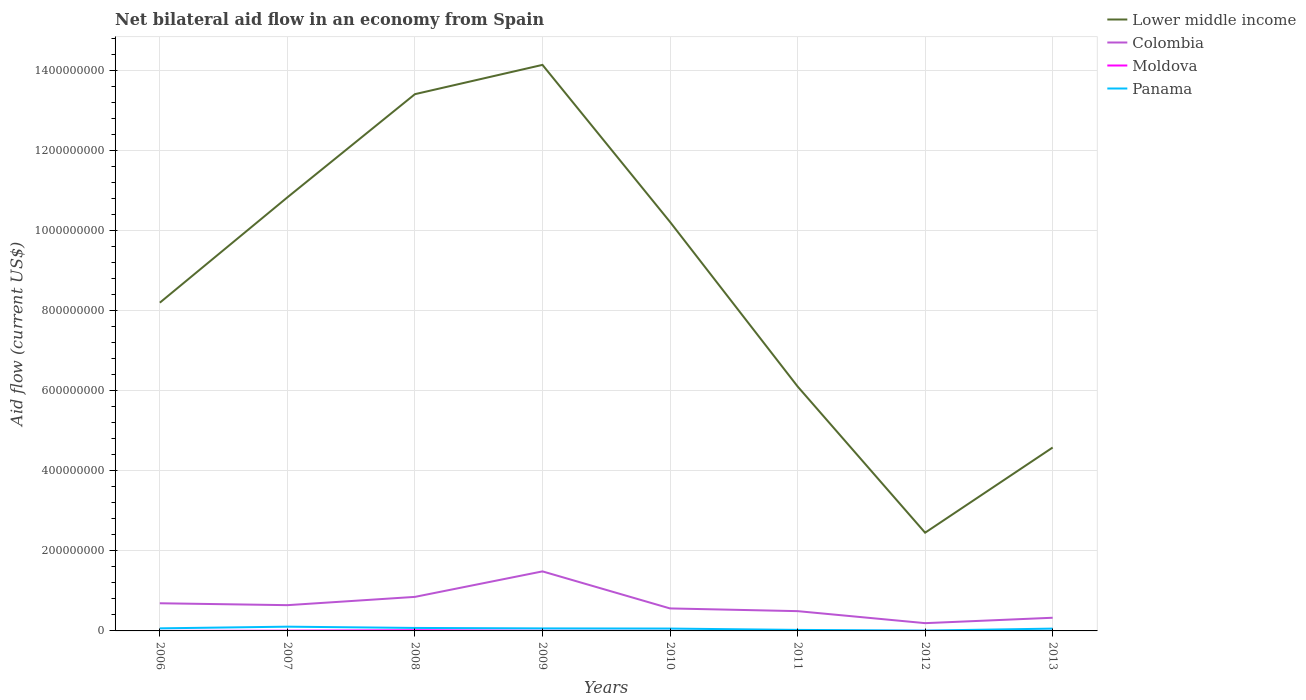Is the number of lines equal to the number of legend labels?
Provide a succinct answer. Yes. Across all years, what is the maximum net bilateral aid flow in Moldova?
Make the answer very short. 10000. What is the total net bilateral aid flow in Panama in the graph?
Ensure brevity in your answer.  4.83e+06. What is the difference between the highest and the second highest net bilateral aid flow in Colombia?
Make the answer very short. 1.29e+08. What is the difference between the highest and the lowest net bilateral aid flow in Moldova?
Ensure brevity in your answer.  3. Is the net bilateral aid flow in Colombia strictly greater than the net bilateral aid flow in Panama over the years?
Your answer should be very brief. No. How many years are there in the graph?
Make the answer very short. 8. What is the difference between two consecutive major ticks on the Y-axis?
Keep it short and to the point. 2.00e+08. Does the graph contain any zero values?
Your answer should be very brief. No. Does the graph contain grids?
Ensure brevity in your answer.  Yes. How many legend labels are there?
Make the answer very short. 4. What is the title of the graph?
Provide a succinct answer. Net bilateral aid flow in an economy from Spain. Does "Comoros" appear as one of the legend labels in the graph?
Your answer should be compact. No. What is the label or title of the X-axis?
Provide a succinct answer. Years. What is the Aid flow (current US$) in Lower middle income in 2006?
Keep it short and to the point. 8.19e+08. What is the Aid flow (current US$) in Colombia in 2006?
Provide a short and direct response. 6.90e+07. What is the Aid flow (current US$) in Moldova in 2006?
Ensure brevity in your answer.  10000. What is the Aid flow (current US$) of Panama in 2006?
Your answer should be compact. 6.43e+06. What is the Aid flow (current US$) of Lower middle income in 2007?
Your answer should be very brief. 1.08e+09. What is the Aid flow (current US$) in Colombia in 2007?
Provide a short and direct response. 6.43e+07. What is the Aid flow (current US$) of Moldova in 2007?
Give a very brief answer. 6.50e+05. What is the Aid flow (current US$) in Panama in 2007?
Your answer should be compact. 1.06e+07. What is the Aid flow (current US$) of Lower middle income in 2008?
Provide a short and direct response. 1.34e+09. What is the Aid flow (current US$) of Colombia in 2008?
Offer a terse response. 8.50e+07. What is the Aid flow (current US$) in Moldova in 2008?
Your response must be concise. 1.80e+06. What is the Aid flow (current US$) in Panama in 2008?
Keep it short and to the point. 7.44e+06. What is the Aid flow (current US$) of Lower middle income in 2009?
Your answer should be very brief. 1.41e+09. What is the Aid flow (current US$) of Colombia in 2009?
Give a very brief answer. 1.49e+08. What is the Aid flow (current US$) in Moldova in 2009?
Make the answer very short. 3.90e+05. What is the Aid flow (current US$) in Panama in 2009?
Your answer should be very brief. 6.27e+06. What is the Aid flow (current US$) of Lower middle income in 2010?
Make the answer very short. 1.02e+09. What is the Aid flow (current US$) in Colombia in 2010?
Offer a terse response. 5.62e+07. What is the Aid flow (current US$) in Moldova in 2010?
Offer a very short reply. 6.00e+04. What is the Aid flow (current US$) in Panama in 2010?
Your response must be concise. 5.87e+06. What is the Aid flow (current US$) of Lower middle income in 2011?
Offer a terse response. 6.10e+08. What is the Aid flow (current US$) in Colombia in 2011?
Give a very brief answer. 4.94e+07. What is the Aid flow (current US$) of Panama in 2011?
Ensure brevity in your answer.  2.54e+06. What is the Aid flow (current US$) in Lower middle income in 2012?
Offer a very short reply. 2.45e+08. What is the Aid flow (current US$) of Colombia in 2012?
Provide a short and direct response. 1.94e+07. What is the Aid flow (current US$) in Panama in 2012?
Provide a succinct answer. 8.60e+05. What is the Aid flow (current US$) of Lower middle income in 2013?
Offer a terse response. 4.58e+08. What is the Aid flow (current US$) of Colombia in 2013?
Offer a very short reply. 3.29e+07. What is the Aid flow (current US$) of Panama in 2013?
Give a very brief answer. 5.77e+06. Across all years, what is the maximum Aid flow (current US$) in Lower middle income?
Provide a short and direct response. 1.41e+09. Across all years, what is the maximum Aid flow (current US$) of Colombia?
Ensure brevity in your answer.  1.49e+08. Across all years, what is the maximum Aid flow (current US$) of Moldova?
Your answer should be very brief. 1.80e+06. Across all years, what is the maximum Aid flow (current US$) of Panama?
Ensure brevity in your answer.  1.06e+07. Across all years, what is the minimum Aid flow (current US$) in Lower middle income?
Ensure brevity in your answer.  2.45e+08. Across all years, what is the minimum Aid flow (current US$) of Colombia?
Offer a very short reply. 1.94e+07. Across all years, what is the minimum Aid flow (current US$) in Moldova?
Your answer should be very brief. 10000. Across all years, what is the minimum Aid flow (current US$) in Panama?
Offer a very short reply. 8.60e+05. What is the total Aid flow (current US$) in Lower middle income in the graph?
Your response must be concise. 6.99e+09. What is the total Aid flow (current US$) in Colombia in the graph?
Give a very brief answer. 5.25e+08. What is the total Aid flow (current US$) of Panama in the graph?
Your response must be concise. 4.58e+07. What is the difference between the Aid flow (current US$) in Lower middle income in 2006 and that in 2007?
Provide a short and direct response. -2.63e+08. What is the difference between the Aid flow (current US$) in Colombia in 2006 and that in 2007?
Provide a short and direct response. 4.72e+06. What is the difference between the Aid flow (current US$) in Moldova in 2006 and that in 2007?
Offer a very short reply. -6.40e+05. What is the difference between the Aid flow (current US$) of Panama in 2006 and that in 2007?
Give a very brief answer. -4.17e+06. What is the difference between the Aid flow (current US$) of Lower middle income in 2006 and that in 2008?
Your answer should be very brief. -5.21e+08. What is the difference between the Aid flow (current US$) of Colombia in 2006 and that in 2008?
Keep it short and to the point. -1.60e+07. What is the difference between the Aid flow (current US$) in Moldova in 2006 and that in 2008?
Offer a very short reply. -1.79e+06. What is the difference between the Aid flow (current US$) of Panama in 2006 and that in 2008?
Make the answer very short. -1.01e+06. What is the difference between the Aid flow (current US$) in Lower middle income in 2006 and that in 2009?
Give a very brief answer. -5.94e+08. What is the difference between the Aid flow (current US$) of Colombia in 2006 and that in 2009?
Offer a terse response. -7.96e+07. What is the difference between the Aid flow (current US$) of Moldova in 2006 and that in 2009?
Provide a succinct answer. -3.80e+05. What is the difference between the Aid flow (current US$) of Panama in 2006 and that in 2009?
Provide a short and direct response. 1.60e+05. What is the difference between the Aid flow (current US$) in Lower middle income in 2006 and that in 2010?
Offer a terse response. -2.02e+08. What is the difference between the Aid flow (current US$) of Colombia in 2006 and that in 2010?
Your answer should be compact. 1.29e+07. What is the difference between the Aid flow (current US$) of Moldova in 2006 and that in 2010?
Give a very brief answer. -5.00e+04. What is the difference between the Aid flow (current US$) of Panama in 2006 and that in 2010?
Make the answer very short. 5.60e+05. What is the difference between the Aid flow (current US$) of Lower middle income in 2006 and that in 2011?
Keep it short and to the point. 2.09e+08. What is the difference between the Aid flow (current US$) of Colombia in 2006 and that in 2011?
Offer a very short reply. 1.96e+07. What is the difference between the Aid flow (current US$) in Moldova in 2006 and that in 2011?
Ensure brevity in your answer.  -3.00e+04. What is the difference between the Aid flow (current US$) in Panama in 2006 and that in 2011?
Keep it short and to the point. 3.89e+06. What is the difference between the Aid flow (current US$) of Lower middle income in 2006 and that in 2012?
Your response must be concise. 5.74e+08. What is the difference between the Aid flow (current US$) in Colombia in 2006 and that in 2012?
Offer a very short reply. 4.96e+07. What is the difference between the Aid flow (current US$) in Moldova in 2006 and that in 2012?
Offer a terse response. -10000. What is the difference between the Aid flow (current US$) in Panama in 2006 and that in 2012?
Provide a succinct answer. 5.57e+06. What is the difference between the Aid flow (current US$) of Lower middle income in 2006 and that in 2013?
Your answer should be compact. 3.62e+08. What is the difference between the Aid flow (current US$) in Colombia in 2006 and that in 2013?
Your answer should be compact. 3.61e+07. What is the difference between the Aid flow (current US$) in Moldova in 2006 and that in 2013?
Your answer should be compact. -2.00e+04. What is the difference between the Aid flow (current US$) of Panama in 2006 and that in 2013?
Provide a succinct answer. 6.60e+05. What is the difference between the Aid flow (current US$) of Lower middle income in 2007 and that in 2008?
Your response must be concise. -2.58e+08. What is the difference between the Aid flow (current US$) in Colombia in 2007 and that in 2008?
Your answer should be compact. -2.07e+07. What is the difference between the Aid flow (current US$) in Moldova in 2007 and that in 2008?
Your answer should be compact. -1.15e+06. What is the difference between the Aid flow (current US$) of Panama in 2007 and that in 2008?
Keep it short and to the point. 3.16e+06. What is the difference between the Aid flow (current US$) of Lower middle income in 2007 and that in 2009?
Give a very brief answer. -3.31e+08. What is the difference between the Aid flow (current US$) in Colombia in 2007 and that in 2009?
Provide a succinct answer. -8.43e+07. What is the difference between the Aid flow (current US$) of Moldova in 2007 and that in 2009?
Ensure brevity in your answer.  2.60e+05. What is the difference between the Aid flow (current US$) of Panama in 2007 and that in 2009?
Keep it short and to the point. 4.33e+06. What is the difference between the Aid flow (current US$) of Lower middle income in 2007 and that in 2010?
Your answer should be compact. 6.13e+07. What is the difference between the Aid flow (current US$) in Colombia in 2007 and that in 2010?
Ensure brevity in your answer.  8.15e+06. What is the difference between the Aid flow (current US$) of Moldova in 2007 and that in 2010?
Make the answer very short. 5.90e+05. What is the difference between the Aid flow (current US$) in Panama in 2007 and that in 2010?
Ensure brevity in your answer.  4.73e+06. What is the difference between the Aid flow (current US$) in Lower middle income in 2007 and that in 2011?
Provide a succinct answer. 4.72e+08. What is the difference between the Aid flow (current US$) of Colombia in 2007 and that in 2011?
Your response must be concise. 1.49e+07. What is the difference between the Aid flow (current US$) of Moldova in 2007 and that in 2011?
Give a very brief answer. 6.10e+05. What is the difference between the Aid flow (current US$) of Panama in 2007 and that in 2011?
Your response must be concise. 8.06e+06. What is the difference between the Aid flow (current US$) of Lower middle income in 2007 and that in 2012?
Ensure brevity in your answer.  8.37e+08. What is the difference between the Aid flow (current US$) in Colombia in 2007 and that in 2012?
Your answer should be very brief. 4.49e+07. What is the difference between the Aid flow (current US$) in Moldova in 2007 and that in 2012?
Provide a short and direct response. 6.30e+05. What is the difference between the Aid flow (current US$) of Panama in 2007 and that in 2012?
Keep it short and to the point. 9.74e+06. What is the difference between the Aid flow (current US$) of Lower middle income in 2007 and that in 2013?
Give a very brief answer. 6.24e+08. What is the difference between the Aid flow (current US$) in Colombia in 2007 and that in 2013?
Offer a terse response. 3.14e+07. What is the difference between the Aid flow (current US$) in Moldova in 2007 and that in 2013?
Offer a very short reply. 6.20e+05. What is the difference between the Aid flow (current US$) in Panama in 2007 and that in 2013?
Provide a short and direct response. 4.83e+06. What is the difference between the Aid flow (current US$) in Lower middle income in 2008 and that in 2009?
Offer a terse response. -7.31e+07. What is the difference between the Aid flow (current US$) in Colombia in 2008 and that in 2009?
Your response must be concise. -6.36e+07. What is the difference between the Aid flow (current US$) in Moldova in 2008 and that in 2009?
Keep it short and to the point. 1.41e+06. What is the difference between the Aid flow (current US$) in Panama in 2008 and that in 2009?
Give a very brief answer. 1.17e+06. What is the difference between the Aid flow (current US$) in Lower middle income in 2008 and that in 2010?
Your response must be concise. 3.19e+08. What is the difference between the Aid flow (current US$) of Colombia in 2008 and that in 2010?
Give a very brief answer. 2.88e+07. What is the difference between the Aid flow (current US$) in Moldova in 2008 and that in 2010?
Your response must be concise. 1.74e+06. What is the difference between the Aid flow (current US$) of Panama in 2008 and that in 2010?
Provide a short and direct response. 1.57e+06. What is the difference between the Aid flow (current US$) in Lower middle income in 2008 and that in 2011?
Make the answer very short. 7.30e+08. What is the difference between the Aid flow (current US$) in Colombia in 2008 and that in 2011?
Your answer should be very brief. 3.56e+07. What is the difference between the Aid flow (current US$) in Moldova in 2008 and that in 2011?
Ensure brevity in your answer.  1.76e+06. What is the difference between the Aid flow (current US$) of Panama in 2008 and that in 2011?
Provide a short and direct response. 4.90e+06. What is the difference between the Aid flow (current US$) in Lower middle income in 2008 and that in 2012?
Your response must be concise. 1.09e+09. What is the difference between the Aid flow (current US$) of Colombia in 2008 and that in 2012?
Provide a succinct answer. 6.56e+07. What is the difference between the Aid flow (current US$) in Moldova in 2008 and that in 2012?
Offer a terse response. 1.78e+06. What is the difference between the Aid flow (current US$) of Panama in 2008 and that in 2012?
Make the answer very short. 6.58e+06. What is the difference between the Aid flow (current US$) of Lower middle income in 2008 and that in 2013?
Provide a short and direct response. 8.82e+08. What is the difference between the Aid flow (current US$) of Colombia in 2008 and that in 2013?
Your answer should be very brief. 5.21e+07. What is the difference between the Aid flow (current US$) of Moldova in 2008 and that in 2013?
Give a very brief answer. 1.77e+06. What is the difference between the Aid flow (current US$) in Panama in 2008 and that in 2013?
Your answer should be very brief. 1.67e+06. What is the difference between the Aid flow (current US$) of Lower middle income in 2009 and that in 2010?
Your answer should be compact. 3.92e+08. What is the difference between the Aid flow (current US$) in Colombia in 2009 and that in 2010?
Your answer should be very brief. 9.25e+07. What is the difference between the Aid flow (current US$) in Lower middle income in 2009 and that in 2011?
Provide a succinct answer. 8.03e+08. What is the difference between the Aid flow (current US$) in Colombia in 2009 and that in 2011?
Offer a terse response. 9.92e+07. What is the difference between the Aid flow (current US$) of Panama in 2009 and that in 2011?
Keep it short and to the point. 3.73e+06. What is the difference between the Aid flow (current US$) of Lower middle income in 2009 and that in 2012?
Make the answer very short. 1.17e+09. What is the difference between the Aid flow (current US$) of Colombia in 2009 and that in 2012?
Give a very brief answer. 1.29e+08. What is the difference between the Aid flow (current US$) of Panama in 2009 and that in 2012?
Provide a succinct answer. 5.41e+06. What is the difference between the Aid flow (current US$) in Lower middle income in 2009 and that in 2013?
Offer a terse response. 9.55e+08. What is the difference between the Aid flow (current US$) of Colombia in 2009 and that in 2013?
Your response must be concise. 1.16e+08. What is the difference between the Aid flow (current US$) in Lower middle income in 2010 and that in 2011?
Your response must be concise. 4.11e+08. What is the difference between the Aid flow (current US$) in Colombia in 2010 and that in 2011?
Give a very brief answer. 6.76e+06. What is the difference between the Aid flow (current US$) in Moldova in 2010 and that in 2011?
Your response must be concise. 2.00e+04. What is the difference between the Aid flow (current US$) in Panama in 2010 and that in 2011?
Provide a succinct answer. 3.33e+06. What is the difference between the Aid flow (current US$) in Lower middle income in 2010 and that in 2012?
Your response must be concise. 7.76e+08. What is the difference between the Aid flow (current US$) of Colombia in 2010 and that in 2012?
Give a very brief answer. 3.68e+07. What is the difference between the Aid flow (current US$) of Moldova in 2010 and that in 2012?
Keep it short and to the point. 4.00e+04. What is the difference between the Aid flow (current US$) in Panama in 2010 and that in 2012?
Your response must be concise. 5.01e+06. What is the difference between the Aid flow (current US$) of Lower middle income in 2010 and that in 2013?
Provide a short and direct response. 5.63e+08. What is the difference between the Aid flow (current US$) in Colombia in 2010 and that in 2013?
Provide a succinct answer. 2.33e+07. What is the difference between the Aid flow (current US$) in Lower middle income in 2011 and that in 2012?
Offer a terse response. 3.65e+08. What is the difference between the Aid flow (current US$) of Colombia in 2011 and that in 2012?
Offer a terse response. 3.00e+07. What is the difference between the Aid flow (current US$) of Panama in 2011 and that in 2012?
Keep it short and to the point. 1.68e+06. What is the difference between the Aid flow (current US$) in Lower middle income in 2011 and that in 2013?
Your answer should be very brief. 1.53e+08. What is the difference between the Aid flow (current US$) in Colombia in 2011 and that in 2013?
Give a very brief answer. 1.65e+07. What is the difference between the Aid flow (current US$) in Panama in 2011 and that in 2013?
Offer a very short reply. -3.23e+06. What is the difference between the Aid flow (current US$) of Lower middle income in 2012 and that in 2013?
Provide a short and direct response. -2.13e+08. What is the difference between the Aid flow (current US$) in Colombia in 2012 and that in 2013?
Ensure brevity in your answer.  -1.35e+07. What is the difference between the Aid flow (current US$) of Moldova in 2012 and that in 2013?
Keep it short and to the point. -10000. What is the difference between the Aid flow (current US$) in Panama in 2012 and that in 2013?
Provide a succinct answer. -4.91e+06. What is the difference between the Aid flow (current US$) in Lower middle income in 2006 and the Aid flow (current US$) in Colombia in 2007?
Your answer should be compact. 7.55e+08. What is the difference between the Aid flow (current US$) of Lower middle income in 2006 and the Aid flow (current US$) of Moldova in 2007?
Offer a very short reply. 8.19e+08. What is the difference between the Aid flow (current US$) in Lower middle income in 2006 and the Aid flow (current US$) in Panama in 2007?
Offer a very short reply. 8.09e+08. What is the difference between the Aid flow (current US$) in Colombia in 2006 and the Aid flow (current US$) in Moldova in 2007?
Your answer should be compact. 6.84e+07. What is the difference between the Aid flow (current US$) in Colombia in 2006 and the Aid flow (current US$) in Panama in 2007?
Keep it short and to the point. 5.84e+07. What is the difference between the Aid flow (current US$) of Moldova in 2006 and the Aid flow (current US$) of Panama in 2007?
Your response must be concise. -1.06e+07. What is the difference between the Aid flow (current US$) of Lower middle income in 2006 and the Aid flow (current US$) of Colombia in 2008?
Offer a very short reply. 7.34e+08. What is the difference between the Aid flow (current US$) in Lower middle income in 2006 and the Aid flow (current US$) in Moldova in 2008?
Make the answer very short. 8.18e+08. What is the difference between the Aid flow (current US$) in Lower middle income in 2006 and the Aid flow (current US$) in Panama in 2008?
Give a very brief answer. 8.12e+08. What is the difference between the Aid flow (current US$) in Colombia in 2006 and the Aid flow (current US$) in Moldova in 2008?
Your answer should be compact. 6.72e+07. What is the difference between the Aid flow (current US$) of Colombia in 2006 and the Aid flow (current US$) of Panama in 2008?
Keep it short and to the point. 6.16e+07. What is the difference between the Aid flow (current US$) in Moldova in 2006 and the Aid flow (current US$) in Panama in 2008?
Offer a very short reply. -7.43e+06. What is the difference between the Aid flow (current US$) of Lower middle income in 2006 and the Aid flow (current US$) of Colombia in 2009?
Give a very brief answer. 6.71e+08. What is the difference between the Aid flow (current US$) of Lower middle income in 2006 and the Aid flow (current US$) of Moldova in 2009?
Ensure brevity in your answer.  8.19e+08. What is the difference between the Aid flow (current US$) in Lower middle income in 2006 and the Aid flow (current US$) in Panama in 2009?
Ensure brevity in your answer.  8.13e+08. What is the difference between the Aid flow (current US$) of Colombia in 2006 and the Aid flow (current US$) of Moldova in 2009?
Offer a terse response. 6.86e+07. What is the difference between the Aid flow (current US$) of Colombia in 2006 and the Aid flow (current US$) of Panama in 2009?
Give a very brief answer. 6.28e+07. What is the difference between the Aid flow (current US$) in Moldova in 2006 and the Aid flow (current US$) in Panama in 2009?
Offer a very short reply. -6.26e+06. What is the difference between the Aid flow (current US$) in Lower middle income in 2006 and the Aid flow (current US$) in Colombia in 2010?
Ensure brevity in your answer.  7.63e+08. What is the difference between the Aid flow (current US$) of Lower middle income in 2006 and the Aid flow (current US$) of Moldova in 2010?
Your response must be concise. 8.19e+08. What is the difference between the Aid flow (current US$) in Lower middle income in 2006 and the Aid flow (current US$) in Panama in 2010?
Ensure brevity in your answer.  8.14e+08. What is the difference between the Aid flow (current US$) of Colombia in 2006 and the Aid flow (current US$) of Moldova in 2010?
Provide a short and direct response. 6.90e+07. What is the difference between the Aid flow (current US$) of Colombia in 2006 and the Aid flow (current US$) of Panama in 2010?
Your answer should be very brief. 6.32e+07. What is the difference between the Aid flow (current US$) of Moldova in 2006 and the Aid flow (current US$) of Panama in 2010?
Ensure brevity in your answer.  -5.86e+06. What is the difference between the Aid flow (current US$) of Lower middle income in 2006 and the Aid flow (current US$) of Colombia in 2011?
Keep it short and to the point. 7.70e+08. What is the difference between the Aid flow (current US$) of Lower middle income in 2006 and the Aid flow (current US$) of Moldova in 2011?
Offer a terse response. 8.19e+08. What is the difference between the Aid flow (current US$) in Lower middle income in 2006 and the Aid flow (current US$) in Panama in 2011?
Your answer should be compact. 8.17e+08. What is the difference between the Aid flow (current US$) in Colombia in 2006 and the Aid flow (current US$) in Moldova in 2011?
Provide a short and direct response. 6.90e+07. What is the difference between the Aid flow (current US$) of Colombia in 2006 and the Aid flow (current US$) of Panama in 2011?
Offer a terse response. 6.65e+07. What is the difference between the Aid flow (current US$) in Moldova in 2006 and the Aid flow (current US$) in Panama in 2011?
Provide a succinct answer. -2.53e+06. What is the difference between the Aid flow (current US$) of Lower middle income in 2006 and the Aid flow (current US$) of Colombia in 2012?
Keep it short and to the point. 8.00e+08. What is the difference between the Aid flow (current US$) of Lower middle income in 2006 and the Aid flow (current US$) of Moldova in 2012?
Your response must be concise. 8.19e+08. What is the difference between the Aid flow (current US$) of Lower middle income in 2006 and the Aid flow (current US$) of Panama in 2012?
Your response must be concise. 8.19e+08. What is the difference between the Aid flow (current US$) of Colombia in 2006 and the Aid flow (current US$) of Moldova in 2012?
Your answer should be compact. 6.90e+07. What is the difference between the Aid flow (current US$) of Colombia in 2006 and the Aid flow (current US$) of Panama in 2012?
Your answer should be very brief. 6.82e+07. What is the difference between the Aid flow (current US$) in Moldova in 2006 and the Aid flow (current US$) in Panama in 2012?
Your response must be concise. -8.50e+05. What is the difference between the Aid flow (current US$) of Lower middle income in 2006 and the Aid flow (current US$) of Colombia in 2013?
Keep it short and to the point. 7.86e+08. What is the difference between the Aid flow (current US$) of Lower middle income in 2006 and the Aid flow (current US$) of Moldova in 2013?
Give a very brief answer. 8.19e+08. What is the difference between the Aid flow (current US$) in Lower middle income in 2006 and the Aid flow (current US$) in Panama in 2013?
Give a very brief answer. 8.14e+08. What is the difference between the Aid flow (current US$) of Colombia in 2006 and the Aid flow (current US$) of Moldova in 2013?
Offer a terse response. 6.90e+07. What is the difference between the Aid flow (current US$) of Colombia in 2006 and the Aid flow (current US$) of Panama in 2013?
Your answer should be compact. 6.32e+07. What is the difference between the Aid flow (current US$) in Moldova in 2006 and the Aid flow (current US$) in Panama in 2013?
Ensure brevity in your answer.  -5.76e+06. What is the difference between the Aid flow (current US$) in Lower middle income in 2007 and the Aid flow (current US$) in Colombia in 2008?
Offer a terse response. 9.97e+08. What is the difference between the Aid flow (current US$) of Lower middle income in 2007 and the Aid flow (current US$) of Moldova in 2008?
Offer a very short reply. 1.08e+09. What is the difference between the Aid flow (current US$) in Lower middle income in 2007 and the Aid flow (current US$) in Panama in 2008?
Keep it short and to the point. 1.07e+09. What is the difference between the Aid flow (current US$) in Colombia in 2007 and the Aid flow (current US$) in Moldova in 2008?
Offer a very short reply. 6.25e+07. What is the difference between the Aid flow (current US$) of Colombia in 2007 and the Aid flow (current US$) of Panama in 2008?
Keep it short and to the point. 5.69e+07. What is the difference between the Aid flow (current US$) of Moldova in 2007 and the Aid flow (current US$) of Panama in 2008?
Give a very brief answer. -6.79e+06. What is the difference between the Aid flow (current US$) in Lower middle income in 2007 and the Aid flow (current US$) in Colombia in 2009?
Provide a succinct answer. 9.34e+08. What is the difference between the Aid flow (current US$) of Lower middle income in 2007 and the Aid flow (current US$) of Moldova in 2009?
Offer a terse response. 1.08e+09. What is the difference between the Aid flow (current US$) of Lower middle income in 2007 and the Aid flow (current US$) of Panama in 2009?
Your answer should be very brief. 1.08e+09. What is the difference between the Aid flow (current US$) in Colombia in 2007 and the Aid flow (current US$) in Moldova in 2009?
Make the answer very short. 6.39e+07. What is the difference between the Aid flow (current US$) of Colombia in 2007 and the Aid flow (current US$) of Panama in 2009?
Offer a terse response. 5.80e+07. What is the difference between the Aid flow (current US$) in Moldova in 2007 and the Aid flow (current US$) in Panama in 2009?
Offer a terse response. -5.62e+06. What is the difference between the Aid flow (current US$) in Lower middle income in 2007 and the Aid flow (current US$) in Colombia in 2010?
Keep it short and to the point. 1.03e+09. What is the difference between the Aid flow (current US$) in Lower middle income in 2007 and the Aid flow (current US$) in Moldova in 2010?
Provide a succinct answer. 1.08e+09. What is the difference between the Aid flow (current US$) of Lower middle income in 2007 and the Aid flow (current US$) of Panama in 2010?
Your answer should be compact. 1.08e+09. What is the difference between the Aid flow (current US$) in Colombia in 2007 and the Aid flow (current US$) in Moldova in 2010?
Your answer should be compact. 6.42e+07. What is the difference between the Aid flow (current US$) of Colombia in 2007 and the Aid flow (current US$) of Panama in 2010?
Offer a terse response. 5.84e+07. What is the difference between the Aid flow (current US$) in Moldova in 2007 and the Aid flow (current US$) in Panama in 2010?
Keep it short and to the point. -5.22e+06. What is the difference between the Aid flow (current US$) of Lower middle income in 2007 and the Aid flow (current US$) of Colombia in 2011?
Keep it short and to the point. 1.03e+09. What is the difference between the Aid flow (current US$) in Lower middle income in 2007 and the Aid flow (current US$) in Moldova in 2011?
Offer a very short reply. 1.08e+09. What is the difference between the Aid flow (current US$) in Lower middle income in 2007 and the Aid flow (current US$) in Panama in 2011?
Ensure brevity in your answer.  1.08e+09. What is the difference between the Aid flow (current US$) in Colombia in 2007 and the Aid flow (current US$) in Moldova in 2011?
Provide a succinct answer. 6.43e+07. What is the difference between the Aid flow (current US$) of Colombia in 2007 and the Aid flow (current US$) of Panama in 2011?
Offer a very short reply. 6.18e+07. What is the difference between the Aid flow (current US$) of Moldova in 2007 and the Aid flow (current US$) of Panama in 2011?
Your response must be concise. -1.89e+06. What is the difference between the Aid flow (current US$) of Lower middle income in 2007 and the Aid flow (current US$) of Colombia in 2012?
Provide a short and direct response. 1.06e+09. What is the difference between the Aid flow (current US$) of Lower middle income in 2007 and the Aid flow (current US$) of Moldova in 2012?
Ensure brevity in your answer.  1.08e+09. What is the difference between the Aid flow (current US$) of Lower middle income in 2007 and the Aid flow (current US$) of Panama in 2012?
Make the answer very short. 1.08e+09. What is the difference between the Aid flow (current US$) in Colombia in 2007 and the Aid flow (current US$) in Moldova in 2012?
Your answer should be compact. 6.43e+07. What is the difference between the Aid flow (current US$) of Colombia in 2007 and the Aid flow (current US$) of Panama in 2012?
Offer a very short reply. 6.34e+07. What is the difference between the Aid flow (current US$) in Moldova in 2007 and the Aid flow (current US$) in Panama in 2012?
Give a very brief answer. -2.10e+05. What is the difference between the Aid flow (current US$) in Lower middle income in 2007 and the Aid flow (current US$) in Colombia in 2013?
Provide a succinct answer. 1.05e+09. What is the difference between the Aid flow (current US$) of Lower middle income in 2007 and the Aid flow (current US$) of Moldova in 2013?
Ensure brevity in your answer.  1.08e+09. What is the difference between the Aid flow (current US$) in Lower middle income in 2007 and the Aid flow (current US$) in Panama in 2013?
Provide a short and direct response. 1.08e+09. What is the difference between the Aid flow (current US$) of Colombia in 2007 and the Aid flow (current US$) of Moldova in 2013?
Provide a succinct answer. 6.43e+07. What is the difference between the Aid flow (current US$) of Colombia in 2007 and the Aid flow (current US$) of Panama in 2013?
Make the answer very short. 5.85e+07. What is the difference between the Aid flow (current US$) in Moldova in 2007 and the Aid flow (current US$) in Panama in 2013?
Your answer should be compact. -5.12e+06. What is the difference between the Aid flow (current US$) of Lower middle income in 2008 and the Aid flow (current US$) of Colombia in 2009?
Your answer should be compact. 1.19e+09. What is the difference between the Aid flow (current US$) of Lower middle income in 2008 and the Aid flow (current US$) of Moldova in 2009?
Your answer should be compact. 1.34e+09. What is the difference between the Aid flow (current US$) in Lower middle income in 2008 and the Aid flow (current US$) in Panama in 2009?
Provide a short and direct response. 1.33e+09. What is the difference between the Aid flow (current US$) of Colombia in 2008 and the Aid flow (current US$) of Moldova in 2009?
Provide a succinct answer. 8.46e+07. What is the difference between the Aid flow (current US$) of Colombia in 2008 and the Aid flow (current US$) of Panama in 2009?
Make the answer very short. 7.87e+07. What is the difference between the Aid flow (current US$) of Moldova in 2008 and the Aid flow (current US$) of Panama in 2009?
Provide a succinct answer. -4.47e+06. What is the difference between the Aid flow (current US$) in Lower middle income in 2008 and the Aid flow (current US$) in Colombia in 2010?
Offer a very short reply. 1.28e+09. What is the difference between the Aid flow (current US$) of Lower middle income in 2008 and the Aid flow (current US$) of Moldova in 2010?
Give a very brief answer. 1.34e+09. What is the difference between the Aid flow (current US$) in Lower middle income in 2008 and the Aid flow (current US$) in Panama in 2010?
Provide a succinct answer. 1.33e+09. What is the difference between the Aid flow (current US$) of Colombia in 2008 and the Aid flow (current US$) of Moldova in 2010?
Give a very brief answer. 8.49e+07. What is the difference between the Aid flow (current US$) of Colombia in 2008 and the Aid flow (current US$) of Panama in 2010?
Provide a short and direct response. 7.91e+07. What is the difference between the Aid flow (current US$) of Moldova in 2008 and the Aid flow (current US$) of Panama in 2010?
Provide a short and direct response. -4.07e+06. What is the difference between the Aid flow (current US$) of Lower middle income in 2008 and the Aid flow (current US$) of Colombia in 2011?
Make the answer very short. 1.29e+09. What is the difference between the Aid flow (current US$) of Lower middle income in 2008 and the Aid flow (current US$) of Moldova in 2011?
Provide a short and direct response. 1.34e+09. What is the difference between the Aid flow (current US$) in Lower middle income in 2008 and the Aid flow (current US$) in Panama in 2011?
Provide a short and direct response. 1.34e+09. What is the difference between the Aid flow (current US$) of Colombia in 2008 and the Aid flow (current US$) of Moldova in 2011?
Your answer should be compact. 8.49e+07. What is the difference between the Aid flow (current US$) in Colombia in 2008 and the Aid flow (current US$) in Panama in 2011?
Offer a terse response. 8.24e+07. What is the difference between the Aid flow (current US$) in Moldova in 2008 and the Aid flow (current US$) in Panama in 2011?
Offer a terse response. -7.40e+05. What is the difference between the Aid flow (current US$) in Lower middle income in 2008 and the Aid flow (current US$) in Colombia in 2012?
Give a very brief answer. 1.32e+09. What is the difference between the Aid flow (current US$) in Lower middle income in 2008 and the Aid flow (current US$) in Moldova in 2012?
Offer a terse response. 1.34e+09. What is the difference between the Aid flow (current US$) in Lower middle income in 2008 and the Aid flow (current US$) in Panama in 2012?
Your response must be concise. 1.34e+09. What is the difference between the Aid flow (current US$) in Colombia in 2008 and the Aid flow (current US$) in Moldova in 2012?
Ensure brevity in your answer.  8.50e+07. What is the difference between the Aid flow (current US$) of Colombia in 2008 and the Aid flow (current US$) of Panama in 2012?
Your answer should be very brief. 8.41e+07. What is the difference between the Aid flow (current US$) of Moldova in 2008 and the Aid flow (current US$) of Panama in 2012?
Give a very brief answer. 9.40e+05. What is the difference between the Aid flow (current US$) in Lower middle income in 2008 and the Aid flow (current US$) in Colombia in 2013?
Offer a terse response. 1.31e+09. What is the difference between the Aid flow (current US$) of Lower middle income in 2008 and the Aid flow (current US$) of Moldova in 2013?
Provide a short and direct response. 1.34e+09. What is the difference between the Aid flow (current US$) in Lower middle income in 2008 and the Aid flow (current US$) in Panama in 2013?
Offer a very short reply. 1.33e+09. What is the difference between the Aid flow (current US$) in Colombia in 2008 and the Aid flow (current US$) in Moldova in 2013?
Offer a very short reply. 8.49e+07. What is the difference between the Aid flow (current US$) of Colombia in 2008 and the Aid flow (current US$) of Panama in 2013?
Offer a very short reply. 7.92e+07. What is the difference between the Aid flow (current US$) of Moldova in 2008 and the Aid flow (current US$) of Panama in 2013?
Give a very brief answer. -3.97e+06. What is the difference between the Aid flow (current US$) in Lower middle income in 2009 and the Aid flow (current US$) in Colombia in 2010?
Give a very brief answer. 1.36e+09. What is the difference between the Aid flow (current US$) in Lower middle income in 2009 and the Aid flow (current US$) in Moldova in 2010?
Your response must be concise. 1.41e+09. What is the difference between the Aid flow (current US$) in Lower middle income in 2009 and the Aid flow (current US$) in Panama in 2010?
Your response must be concise. 1.41e+09. What is the difference between the Aid flow (current US$) in Colombia in 2009 and the Aid flow (current US$) in Moldova in 2010?
Your answer should be compact. 1.49e+08. What is the difference between the Aid flow (current US$) in Colombia in 2009 and the Aid flow (current US$) in Panama in 2010?
Make the answer very short. 1.43e+08. What is the difference between the Aid flow (current US$) of Moldova in 2009 and the Aid flow (current US$) of Panama in 2010?
Your response must be concise. -5.48e+06. What is the difference between the Aid flow (current US$) of Lower middle income in 2009 and the Aid flow (current US$) of Colombia in 2011?
Offer a very short reply. 1.36e+09. What is the difference between the Aid flow (current US$) in Lower middle income in 2009 and the Aid flow (current US$) in Moldova in 2011?
Offer a terse response. 1.41e+09. What is the difference between the Aid flow (current US$) of Lower middle income in 2009 and the Aid flow (current US$) of Panama in 2011?
Provide a succinct answer. 1.41e+09. What is the difference between the Aid flow (current US$) in Colombia in 2009 and the Aid flow (current US$) in Moldova in 2011?
Keep it short and to the point. 1.49e+08. What is the difference between the Aid flow (current US$) in Colombia in 2009 and the Aid flow (current US$) in Panama in 2011?
Ensure brevity in your answer.  1.46e+08. What is the difference between the Aid flow (current US$) in Moldova in 2009 and the Aid flow (current US$) in Panama in 2011?
Provide a succinct answer. -2.15e+06. What is the difference between the Aid flow (current US$) in Lower middle income in 2009 and the Aid flow (current US$) in Colombia in 2012?
Offer a very short reply. 1.39e+09. What is the difference between the Aid flow (current US$) of Lower middle income in 2009 and the Aid flow (current US$) of Moldova in 2012?
Offer a terse response. 1.41e+09. What is the difference between the Aid flow (current US$) of Lower middle income in 2009 and the Aid flow (current US$) of Panama in 2012?
Offer a terse response. 1.41e+09. What is the difference between the Aid flow (current US$) of Colombia in 2009 and the Aid flow (current US$) of Moldova in 2012?
Give a very brief answer. 1.49e+08. What is the difference between the Aid flow (current US$) in Colombia in 2009 and the Aid flow (current US$) in Panama in 2012?
Keep it short and to the point. 1.48e+08. What is the difference between the Aid flow (current US$) of Moldova in 2009 and the Aid flow (current US$) of Panama in 2012?
Make the answer very short. -4.70e+05. What is the difference between the Aid flow (current US$) of Lower middle income in 2009 and the Aid flow (current US$) of Colombia in 2013?
Your answer should be compact. 1.38e+09. What is the difference between the Aid flow (current US$) in Lower middle income in 2009 and the Aid flow (current US$) in Moldova in 2013?
Offer a very short reply. 1.41e+09. What is the difference between the Aid flow (current US$) in Lower middle income in 2009 and the Aid flow (current US$) in Panama in 2013?
Ensure brevity in your answer.  1.41e+09. What is the difference between the Aid flow (current US$) of Colombia in 2009 and the Aid flow (current US$) of Moldova in 2013?
Provide a succinct answer. 1.49e+08. What is the difference between the Aid flow (current US$) in Colombia in 2009 and the Aid flow (current US$) in Panama in 2013?
Offer a terse response. 1.43e+08. What is the difference between the Aid flow (current US$) in Moldova in 2009 and the Aid flow (current US$) in Panama in 2013?
Offer a terse response. -5.38e+06. What is the difference between the Aid flow (current US$) of Lower middle income in 2010 and the Aid flow (current US$) of Colombia in 2011?
Offer a very short reply. 9.72e+08. What is the difference between the Aid flow (current US$) in Lower middle income in 2010 and the Aid flow (current US$) in Moldova in 2011?
Provide a short and direct response. 1.02e+09. What is the difference between the Aid flow (current US$) in Lower middle income in 2010 and the Aid flow (current US$) in Panama in 2011?
Provide a succinct answer. 1.02e+09. What is the difference between the Aid flow (current US$) of Colombia in 2010 and the Aid flow (current US$) of Moldova in 2011?
Ensure brevity in your answer.  5.61e+07. What is the difference between the Aid flow (current US$) of Colombia in 2010 and the Aid flow (current US$) of Panama in 2011?
Your response must be concise. 5.36e+07. What is the difference between the Aid flow (current US$) of Moldova in 2010 and the Aid flow (current US$) of Panama in 2011?
Provide a succinct answer. -2.48e+06. What is the difference between the Aid flow (current US$) in Lower middle income in 2010 and the Aid flow (current US$) in Colombia in 2012?
Give a very brief answer. 1.00e+09. What is the difference between the Aid flow (current US$) of Lower middle income in 2010 and the Aid flow (current US$) of Moldova in 2012?
Offer a very short reply. 1.02e+09. What is the difference between the Aid flow (current US$) in Lower middle income in 2010 and the Aid flow (current US$) in Panama in 2012?
Keep it short and to the point. 1.02e+09. What is the difference between the Aid flow (current US$) of Colombia in 2010 and the Aid flow (current US$) of Moldova in 2012?
Make the answer very short. 5.61e+07. What is the difference between the Aid flow (current US$) of Colombia in 2010 and the Aid flow (current US$) of Panama in 2012?
Give a very brief answer. 5.53e+07. What is the difference between the Aid flow (current US$) of Moldova in 2010 and the Aid flow (current US$) of Panama in 2012?
Your answer should be very brief. -8.00e+05. What is the difference between the Aid flow (current US$) in Lower middle income in 2010 and the Aid flow (current US$) in Colombia in 2013?
Your answer should be very brief. 9.88e+08. What is the difference between the Aid flow (current US$) of Lower middle income in 2010 and the Aid flow (current US$) of Moldova in 2013?
Your response must be concise. 1.02e+09. What is the difference between the Aid flow (current US$) of Lower middle income in 2010 and the Aid flow (current US$) of Panama in 2013?
Give a very brief answer. 1.02e+09. What is the difference between the Aid flow (current US$) of Colombia in 2010 and the Aid flow (current US$) of Moldova in 2013?
Provide a succinct answer. 5.61e+07. What is the difference between the Aid flow (current US$) of Colombia in 2010 and the Aid flow (current US$) of Panama in 2013?
Your response must be concise. 5.04e+07. What is the difference between the Aid flow (current US$) of Moldova in 2010 and the Aid flow (current US$) of Panama in 2013?
Provide a short and direct response. -5.71e+06. What is the difference between the Aid flow (current US$) in Lower middle income in 2011 and the Aid flow (current US$) in Colombia in 2012?
Provide a succinct answer. 5.91e+08. What is the difference between the Aid flow (current US$) of Lower middle income in 2011 and the Aid flow (current US$) of Moldova in 2012?
Your answer should be very brief. 6.10e+08. What is the difference between the Aid flow (current US$) in Lower middle income in 2011 and the Aid flow (current US$) in Panama in 2012?
Offer a very short reply. 6.10e+08. What is the difference between the Aid flow (current US$) in Colombia in 2011 and the Aid flow (current US$) in Moldova in 2012?
Provide a succinct answer. 4.94e+07. What is the difference between the Aid flow (current US$) in Colombia in 2011 and the Aid flow (current US$) in Panama in 2012?
Keep it short and to the point. 4.85e+07. What is the difference between the Aid flow (current US$) in Moldova in 2011 and the Aid flow (current US$) in Panama in 2012?
Your response must be concise. -8.20e+05. What is the difference between the Aid flow (current US$) of Lower middle income in 2011 and the Aid flow (current US$) of Colombia in 2013?
Your response must be concise. 5.77e+08. What is the difference between the Aid flow (current US$) of Lower middle income in 2011 and the Aid flow (current US$) of Moldova in 2013?
Provide a succinct answer. 6.10e+08. What is the difference between the Aid flow (current US$) of Lower middle income in 2011 and the Aid flow (current US$) of Panama in 2013?
Keep it short and to the point. 6.05e+08. What is the difference between the Aid flow (current US$) of Colombia in 2011 and the Aid flow (current US$) of Moldova in 2013?
Provide a short and direct response. 4.94e+07. What is the difference between the Aid flow (current US$) of Colombia in 2011 and the Aid flow (current US$) of Panama in 2013?
Provide a short and direct response. 4.36e+07. What is the difference between the Aid flow (current US$) in Moldova in 2011 and the Aid flow (current US$) in Panama in 2013?
Offer a very short reply. -5.73e+06. What is the difference between the Aid flow (current US$) of Lower middle income in 2012 and the Aid flow (current US$) of Colombia in 2013?
Your response must be concise. 2.12e+08. What is the difference between the Aid flow (current US$) in Lower middle income in 2012 and the Aid flow (current US$) in Moldova in 2013?
Offer a terse response. 2.45e+08. What is the difference between the Aid flow (current US$) in Lower middle income in 2012 and the Aid flow (current US$) in Panama in 2013?
Provide a succinct answer. 2.39e+08. What is the difference between the Aid flow (current US$) in Colombia in 2012 and the Aid flow (current US$) in Moldova in 2013?
Keep it short and to the point. 1.94e+07. What is the difference between the Aid flow (current US$) of Colombia in 2012 and the Aid flow (current US$) of Panama in 2013?
Give a very brief answer. 1.36e+07. What is the difference between the Aid flow (current US$) in Moldova in 2012 and the Aid flow (current US$) in Panama in 2013?
Offer a very short reply. -5.75e+06. What is the average Aid flow (current US$) of Lower middle income per year?
Offer a terse response. 8.74e+08. What is the average Aid flow (current US$) in Colombia per year?
Make the answer very short. 6.56e+07. What is the average Aid flow (current US$) in Moldova per year?
Offer a terse response. 3.75e+05. What is the average Aid flow (current US$) of Panama per year?
Your response must be concise. 5.72e+06. In the year 2006, what is the difference between the Aid flow (current US$) of Lower middle income and Aid flow (current US$) of Colombia?
Provide a succinct answer. 7.50e+08. In the year 2006, what is the difference between the Aid flow (current US$) in Lower middle income and Aid flow (current US$) in Moldova?
Offer a very short reply. 8.19e+08. In the year 2006, what is the difference between the Aid flow (current US$) of Lower middle income and Aid flow (current US$) of Panama?
Provide a short and direct response. 8.13e+08. In the year 2006, what is the difference between the Aid flow (current US$) of Colombia and Aid flow (current US$) of Moldova?
Your response must be concise. 6.90e+07. In the year 2006, what is the difference between the Aid flow (current US$) in Colombia and Aid flow (current US$) in Panama?
Provide a short and direct response. 6.26e+07. In the year 2006, what is the difference between the Aid flow (current US$) of Moldova and Aid flow (current US$) of Panama?
Provide a short and direct response. -6.42e+06. In the year 2007, what is the difference between the Aid flow (current US$) of Lower middle income and Aid flow (current US$) of Colombia?
Provide a short and direct response. 1.02e+09. In the year 2007, what is the difference between the Aid flow (current US$) in Lower middle income and Aid flow (current US$) in Moldova?
Provide a short and direct response. 1.08e+09. In the year 2007, what is the difference between the Aid flow (current US$) in Lower middle income and Aid flow (current US$) in Panama?
Your answer should be very brief. 1.07e+09. In the year 2007, what is the difference between the Aid flow (current US$) in Colombia and Aid flow (current US$) in Moldova?
Your answer should be very brief. 6.36e+07. In the year 2007, what is the difference between the Aid flow (current US$) in Colombia and Aid flow (current US$) in Panama?
Provide a short and direct response. 5.37e+07. In the year 2007, what is the difference between the Aid flow (current US$) in Moldova and Aid flow (current US$) in Panama?
Your answer should be compact. -9.95e+06. In the year 2008, what is the difference between the Aid flow (current US$) in Lower middle income and Aid flow (current US$) in Colombia?
Your response must be concise. 1.25e+09. In the year 2008, what is the difference between the Aid flow (current US$) of Lower middle income and Aid flow (current US$) of Moldova?
Provide a short and direct response. 1.34e+09. In the year 2008, what is the difference between the Aid flow (current US$) in Lower middle income and Aid flow (current US$) in Panama?
Your answer should be very brief. 1.33e+09. In the year 2008, what is the difference between the Aid flow (current US$) in Colombia and Aid flow (current US$) in Moldova?
Provide a short and direct response. 8.32e+07. In the year 2008, what is the difference between the Aid flow (current US$) in Colombia and Aid flow (current US$) in Panama?
Keep it short and to the point. 7.75e+07. In the year 2008, what is the difference between the Aid flow (current US$) of Moldova and Aid flow (current US$) of Panama?
Provide a short and direct response. -5.64e+06. In the year 2009, what is the difference between the Aid flow (current US$) in Lower middle income and Aid flow (current US$) in Colombia?
Give a very brief answer. 1.26e+09. In the year 2009, what is the difference between the Aid flow (current US$) of Lower middle income and Aid flow (current US$) of Moldova?
Make the answer very short. 1.41e+09. In the year 2009, what is the difference between the Aid flow (current US$) of Lower middle income and Aid flow (current US$) of Panama?
Keep it short and to the point. 1.41e+09. In the year 2009, what is the difference between the Aid flow (current US$) in Colombia and Aid flow (current US$) in Moldova?
Ensure brevity in your answer.  1.48e+08. In the year 2009, what is the difference between the Aid flow (current US$) of Colombia and Aid flow (current US$) of Panama?
Your answer should be very brief. 1.42e+08. In the year 2009, what is the difference between the Aid flow (current US$) of Moldova and Aid flow (current US$) of Panama?
Your answer should be compact. -5.88e+06. In the year 2010, what is the difference between the Aid flow (current US$) of Lower middle income and Aid flow (current US$) of Colombia?
Offer a terse response. 9.65e+08. In the year 2010, what is the difference between the Aid flow (current US$) of Lower middle income and Aid flow (current US$) of Moldova?
Offer a terse response. 1.02e+09. In the year 2010, what is the difference between the Aid flow (current US$) in Lower middle income and Aid flow (current US$) in Panama?
Offer a very short reply. 1.02e+09. In the year 2010, what is the difference between the Aid flow (current US$) in Colombia and Aid flow (current US$) in Moldova?
Offer a terse response. 5.61e+07. In the year 2010, what is the difference between the Aid flow (current US$) of Colombia and Aid flow (current US$) of Panama?
Provide a succinct answer. 5.03e+07. In the year 2010, what is the difference between the Aid flow (current US$) of Moldova and Aid flow (current US$) of Panama?
Your response must be concise. -5.81e+06. In the year 2011, what is the difference between the Aid flow (current US$) of Lower middle income and Aid flow (current US$) of Colombia?
Your answer should be compact. 5.61e+08. In the year 2011, what is the difference between the Aid flow (current US$) in Lower middle income and Aid flow (current US$) in Moldova?
Provide a short and direct response. 6.10e+08. In the year 2011, what is the difference between the Aid flow (current US$) of Lower middle income and Aid flow (current US$) of Panama?
Offer a terse response. 6.08e+08. In the year 2011, what is the difference between the Aid flow (current US$) in Colombia and Aid flow (current US$) in Moldova?
Provide a short and direct response. 4.94e+07. In the year 2011, what is the difference between the Aid flow (current US$) of Colombia and Aid flow (current US$) of Panama?
Give a very brief answer. 4.68e+07. In the year 2011, what is the difference between the Aid flow (current US$) in Moldova and Aid flow (current US$) in Panama?
Give a very brief answer. -2.50e+06. In the year 2012, what is the difference between the Aid flow (current US$) in Lower middle income and Aid flow (current US$) in Colombia?
Offer a very short reply. 2.26e+08. In the year 2012, what is the difference between the Aid flow (current US$) of Lower middle income and Aid flow (current US$) of Moldova?
Offer a very short reply. 2.45e+08. In the year 2012, what is the difference between the Aid flow (current US$) in Lower middle income and Aid flow (current US$) in Panama?
Your answer should be very brief. 2.44e+08. In the year 2012, what is the difference between the Aid flow (current US$) in Colombia and Aid flow (current US$) in Moldova?
Your answer should be very brief. 1.94e+07. In the year 2012, what is the difference between the Aid flow (current US$) in Colombia and Aid flow (current US$) in Panama?
Your answer should be compact. 1.85e+07. In the year 2012, what is the difference between the Aid flow (current US$) of Moldova and Aid flow (current US$) of Panama?
Offer a very short reply. -8.40e+05. In the year 2013, what is the difference between the Aid flow (current US$) of Lower middle income and Aid flow (current US$) of Colombia?
Your response must be concise. 4.25e+08. In the year 2013, what is the difference between the Aid flow (current US$) in Lower middle income and Aid flow (current US$) in Moldova?
Your response must be concise. 4.58e+08. In the year 2013, what is the difference between the Aid flow (current US$) of Lower middle income and Aid flow (current US$) of Panama?
Give a very brief answer. 4.52e+08. In the year 2013, what is the difference between the Aid flow (current US$) in Colombia and Aid flow (current US$) in Moldova?
Offer a very short reply. 3.29e+07. In the year 2013, what is the difference between the Aid flow (current US$) of Colombia and Aid flow (current US$) of Panama?
Make the answer very short. 2.71e+07. In the year 2013, what is the difference between the Aid flow (current US$) of Moldova and Aid flow (current US$) of Panama?
Keep it short and to the point. -5.74e+06. What is the ratio of the Aid flow (current US$) of Lower middle income in 2006 to that in 2007?
Offer a very short reply. 0.76. What is the ratio of the Aid flow (current US$) in Colombia in 2006 to that in 2007?
Offer a terse response. 1.07. What is the ratio of the Aid flow (current US$) of Moldova in 2006 to that in 2007?
Your answer should be compact. 0.02. What is the ratio of the Aid flow (current US$) of Panama in 2006 to that in 2007?
Offer a very short reply. 0.61. What is the ratio of the Aid flow (current US$) in Lower middle income in 2006 to that in 2008?
Provide a short and direct response. 0.61. What is the ratio of the Aid flow (current US$) in Colombia in 2006 to that in 2008?
Your answer should be very brief. 0.81. What is the ratio of the Aid flow (current US$) of Moldova in 2006 to that in 2008?
Your response must be concise. 0.01. What is the ratio of the Aid flow (current US$) in Panama in 2006 to that in 2008?
Offer a very short reply. 0.86. What is the ratio of the Aid flow (current US$) of Lower middle income in 2006 to that in 2009?
Your response must be concise. 0.58. What is the ratio of the Aid flow (current US$) in Colombia in 2006 to that in 2009?
Provide a short and direct response. 0.46. What is the ratio of the Aid flow (current US$) of Moldova in 2006 to that in 2009?
Keep it short and to the point. 0.03. What is the ratio of the Aid flow (current US$) of Panama in 2006 to that in 2009?
Give a very brief answer. 1.03. What is the ratio of the Aid flow (current US$) of Lower middle income in 2006 to that in 2010?
Ensure brevity in your answer.  0.8. What is the ratio of the Aid flow (current US$) in Colombia in 2006 to that in 2010?
Your response must be concise. 1.23. What is the ratio of the Aid flow (current US$) in Moldova in 2006 to that in 2010?
Make the answer very short. 0.17. What is the ratio of the Aid flow (current US$) of Panama in 2006 to that in 2010?
Your answer should be compact. 1.1. What is the ratio of the Aid flow (current US$) in Lower middle income in 2006 to that in 2011?
Give a very brief answer. 1.34. What is the ratio of the Aid flow (current US$) in Colombia in 2006 to that in 2011?
Your response must be concise. 1.4. What is the ratio of the Aid flow (current US$) in Panama in 2006 to that in 2011?
Give a very brief answer. 2.53. What is the ratio of the Aid flow (current US$) in Lower middle income in 2006 to that in 2012?
Your answer should be very brief. 3.34. What is the ratio of the Aid flow (current US$) of Colombia in 2006 to that in 2012?
Offer a terse response. 3.56. What is the ratio of the Aid flow (current US$) of Moldova in 2006 to that in 2012?
Your response must be concise. 0.5. What is the ratio of the Aid flow (current US$) of Panama in 2006 to that in 2012?
Provide a succinct answer. 7.48. What is the ratio of the Aid flow (current US$) of Lower middle income in 2006 to that in 2013?
Ensure brevity in your answer.  1.79. What is the ratio of the Aid flow (current US$) in Colombia in 2006 to that in 2013?
Make the answer very short. 2.1. What is the ratio of the Aid flow (current US$) in Panama in 2006 to that in 2013?
Provide a short and direct response. 1.11. What is the ratio of the Aid flow (current US$) of Lower middle income in 2007 to that in 2008?
Offer a very short reply. 0.81. What is the ratio of the Aid flow (current US$) of Colombia in 2007 to that in 2008?
Your answer should be compact. 0.76. What is the ratio of the Aid flow (current US$) of Moldova in 2007 to that in 2008?
Your response must be concise. 0.36. What is the ratio of the Aid flow (current US$) of Panama in 2007 to that in 2008?
Offer a terse response. 1.42. What is the ratio of the Aid flow (current US$) of Lower middle income in 2007 to that in 2009?
Provide a short and direct response. 0.77. What is the ratio of the Aid flow (current US$) of Colombia in 2007 to that in 2009?
Your answer should be compact. 0.43. What is the ratio of the Aid flow (current US$) of Moldova in 2007 to that in 2009?
Ensure brevity in your answer.  1.67. What is the ratio of the Aid flow (current US$) in Panama in 2007 to that in 2009?
Give a very brief answer. 1.69. What is the ratio of the Aid flow (current US$) of Lower middle income in 2007 to that in 2010?
Provide a short and direct response. 1.06. What is the ratio of the Aid flow (current US$) of Colombia in 2007 to that in 2010?
Keep it short and to the point. 1.15. What is the ratio of the Aid flow (current US$) of Moldova in 2007 to that in 2010?
Your response must be concise. 10.83. What is the ratio of the Aid flow (current US$) in Panama in 2007 to that in 2010?
Ensure brevity in your answer.  1.81. What is the ratio of the Aid flow (current US$) in Lower middle income in 2007 to that in 2011?
Your answer should be compact. 1.77. What is the ratio of the Aid flow (current US$) of Colombia in 2007 to that in 2011?
Your answer should be very brief. 1.3. What is the ratio of the Aid flow (current US$) of Moldova in 2007 to that in 2011?
Make the answer very short. 16.25. What is the ratio of the Aid flow (current US$) of Panama in 2007 to that in 2011?
Your answer should be compact. 4.17. What is the ratio of the Aid flow (current US$) of Lower middle income in 2007 to that in 2012?
Ensure brevity in your answer.  4.41. What is the ratio of the Aid flow (current US$) in Colombia in 2007 to that in 2012?
Provide a short and direct response. 3.31. What is the ratio of the Aid flow (current US$) in Moldova in 2007 to that in 2012?
Your response must be concise. 32.5. What is the ratio of the Aid flow (current US$) in Panama in 2007 to that in 2012?
Offer a very short reply. 12.33. What is the ratio of the Aid flow (current US$) in Lower middle income in 2007 to that in 2013?
Your answer should be very brief. 2.36. What is the ratio of the Aid flow (current US$) of Colombia in 2007 to that in 2013?
Give a very brief answer. 1.96. What is the ratio of the Aid flow (current US$) in Moldova in 2007 to that in 2013?
Offer a very short reply. 21.67. What is the ratio of the Aid flow (current US$) of Panama in 2007 to that in 2013?
Give a very brief answer. 1.84. What is the ratio of the Aid flow (current US$) of Lower middle income in 2008 to that in 2009?
Provide a short and direct response. 0.95. What is the ratio of the Aid flow (current US$) in Colombia in 2008 to that in 2009?
Offer a terse response. 0.57. What is the ratio of the Aid flow (current US$) of Moldova in 2008 to that in 2009?
Provide a short and direct response. 4.62. What is the ratio of the Aid flow (current US$) of Panama in 2008 to that in 2009?
Provide a short and direct response. 1.19. What is the ratio of the Aid flow (current US$) of Lower middle income in 2008 to that in 2010?
Offer a very short reply. 1.31. What is the ratio of the Aid flow (current US$) in Colombia in 2008 to that in 2010?
Give a very brief answer. 1.51. What is the ratio of the Aid flow (current US$) in Panama in 2008 to that in 2010?
Your response must be concise. 1.27. What is the ratio of the Aid flow (current US$) of Lower middle income in 2008 to that in 2011?
Your response must be concise. 2.2. What is the ratio of the Aid flow (current US$) in Colombia in 2008 to that in 2011?
Your answer should be compact. 1.72. What is the ratio of the Aid flow (current US$) of Panama in 2008 to that in 2011?
Your answer should be very brief. 2.93. What is the ratio of the Aid flow (current US$) in Lower middle income in 2008 to that in 2012?
Offer a very short reply. 5.46. What is the ratio of the Aid flow (current US$) in Colombia in 2008 to that in 2012?
Offer a very short reply. 4.38. What is the ratio of the Aid flow (current US$) in Moldova in 2008 to that in 2012?
Provide a succinct answer. 90. What is the ratio of the Aid flow (current US$) of Panama in 2008 to that in 2012?
Keep it short and to the point. 8.65. What is the ratio of the Aid flow (current US$) of Lower middle income in 2008 to that in 2013?
Keep it short and to the point. 2.93. What is the ratio of the Aid flow (current US$) in Colombia in 2008 to that in 2013?
Give a very brief answer. 2.58. What is the ratio of the Aid flow (current US$) in Panama in 2008 to that in 2013?
Provide a short and direct response. 1.29. What is the ratio of the Aid flow (current US$) of Lower middle income in 2009 to that in 2010?
Offer a terse response. 1.38. What is the ratio of the Aid flow (current US$) in Colombia in 2009 to that in 2010?
Offer a very short reply. 2.65. What is the ratio of the Aid flow (current US$) in Moldova in 2009 to that in 2010?
Ensure brevity in your answer.  6.5. What is the ratio of the Aid flow (current US$) in Panama in 2009 to that in 2010?
Offer a terse response. 1.07. What is the ratio of the Aid flow (current US$) of Lower middle income in 2009 to that in 2011?
Keep it short and to the point. 2.32. What is the ratio of the Aid flow (current US$) of Colombia in 2009 to that in 2011?
Your answer should be very brief. 3.01. What is the ratio of the Aid flow (current US$) of Moldova in 2009 to that in 2011?
Offer a terse response. 9.75. What is the ratio of the Aid flow (current US$) in Panama in 2009 to that in 2011?
Ensure brevity in your answer.  2.47. What is the ratio of the Aid flow (current US$) of Lower middle income in 2009 to that in 2012?
Your answer should be very brief. 5.76. What is the ratio of the Aid flow (current US$) of Colombia in 2009 to that in 2012?
Give a very brief answer. 7.66. What is the ratio of the Aid flow (current US$) in Panama in 2009 to that in 2012?
Your answer should be very brief. 7.29. What is the ratio of the Aid flow (current US$) in Lower middle income in 2009 to that in 2013?
Offer a terse response. 3.09. What is the ratio of the Aid flow (current US$) of Colombia in 2009 to that in 2013?
Provide a succinct answer. 4.52. What is the ratio of the Aid flow (current US$) in Moldova in 2009 to that in 2013?
Offer a very short reply. 13. What is the ratio of the Aid flow (current US$) in Panama in 2009 to that in 2013?
Give a very brief answer. 1.09. What is the ratio of the Aid flow (current US$) of Lower middle income in 2010 to that in 2011?
Give a very brief answer. 1.67. What is the ratio of the Aid flow (current US$) in Colombia in 2010 to that in 2011?
Your response must be concise. 1.14. What is the ratio of the Aid flow (current US$) of Panama in 2010 to that in 2011?
Provide a short and direct response. 2.31. What is the ratio of the Aid flow (current US$) in Lower middle income in 2010 to that in 2012?
Provide a short and direct response. 4.16. What is the ratio of the Aid flow (current US$) of Colombia in 2010 to that in 2012?
Your answer should be compact. 2.89. What is the ratio of the Aid flow (current US$) of Moldova in 2010 to that in 2012?
Offer a very short reply. 3. What is the ratio of the Aid flow (current US$) of Panama in 2010 to that in 2012?
Your answer should be compact. 6.83. What is the ratio of the Aid flow (current US$) in Lower middle income in 2010 to that in 2013?
Offer a terse response. 2.23. What is the ratio of the Aid flow (current US$) of Colombia in 2010 to that in 2013?
Offer a very short reply. 1.71. What is the ratio of the Aid flow (current US$) of Panama in 2010 to that in 2013?
Offer a very short reply. 1.02. What is the ratio of the Aid flow (current US$) in Lower middle income in 2011 to that in 2012?
Ensure brevity in your answer.  2.49. What is the ratio of the Aid flow (current US$) of Colombia in 2011 to that in 2012?
Make the answer very short. 2.55. What is the ratio of the Aid flow (current US$) of Panama in 2011 to that in 2012?
Your response must be concise. 2.95. What is the ratio of the Aid flow (current US$) of Lower middle income in 2011 to that in 2013?
Your answer should be very brief. 1.33. What is the ratio of the Aid flow (current US$) of Colombia in 2011 to that in 2013?
Make the answer very short. 1.5. What is the ratio of the Aid flow (current US$) of Moldova in 2011 to that in 2013?
Keep it short and to the point. 1.33. What is the ratio of the Aid flow (current US$) of Panama in 2011 to that in 2013?
Your response must be concise. 0.44. What is the ratio of the Aid flow (current US$) of Lower middle income in 2012 to that in 2013?
Ensure brevity in your answer.  0.54. What is the ratio of the Aid flow (current US$) in Colombia in 2012 to that in 2013?
Make the answer very short. 0.59. What is the ratio of the Aid flow (current US$) of Panama in 2012 to that in 2013?
Provide a short and direct response. 0.15. What is the difference between the highest and the second highest Aid flow (current US$) in Lower middle income?
Your answer should be very brief. 7.31e+07. What is the difference between the highest and the second highest Aid flow (current US$) of Colombia?
Keep it short and to the point. 6.36e+07. What is the difference between the highest and the second highest Aid flow (current US$) in Moldova?
Make the answer very short. 1.15e+06. What is the difference between the highest and the second highest Aid flow (current US$) in Panama?
Ensure brevity in your answer.  3.16e+06. What is the difference between the highest and the lowest Aid flow (current US$) in Lower middle income?
Your response must be concise. 1.17e+09. What is the difference between the highest and the lowest Aid flow (current US$) in Colombia?
Provide a succinct answer. 1.29e+08. What is the difference between the highest and the lowest Aid flow (current US$) of Moldova?
Provide a short and direct response. 1.79e+06. What is the difference between the highest and the lowest Aid flow (current US$) in Panama?
Ensure brevity in your answer.  9.74e+06. 